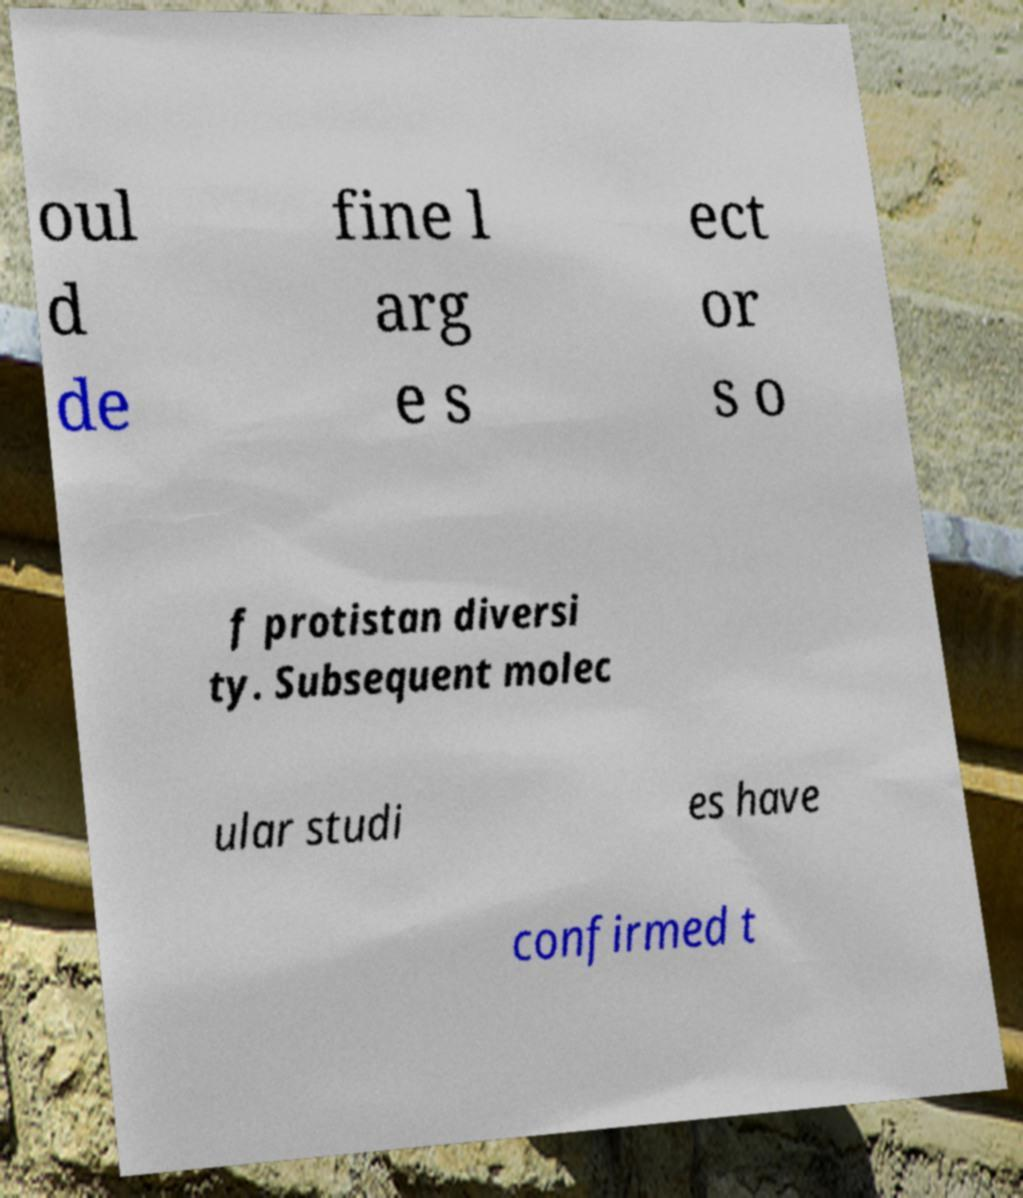Could you assist in decoding the text presented in this image and type it out clearly? oul d de fine l arg e s ect or s o f protistan diversi ty. Subsequent molec ular studi es have confirmed t 